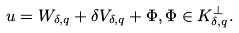Convert formula to latex. <formula><loc_0><loc_0><loc_500><loc_500>u = W _ { \delta , q } + \delta V _ { \delta , q } + \Phi , \Phi \in K _ { \delta , q } ^ { \bot } .</formula> 